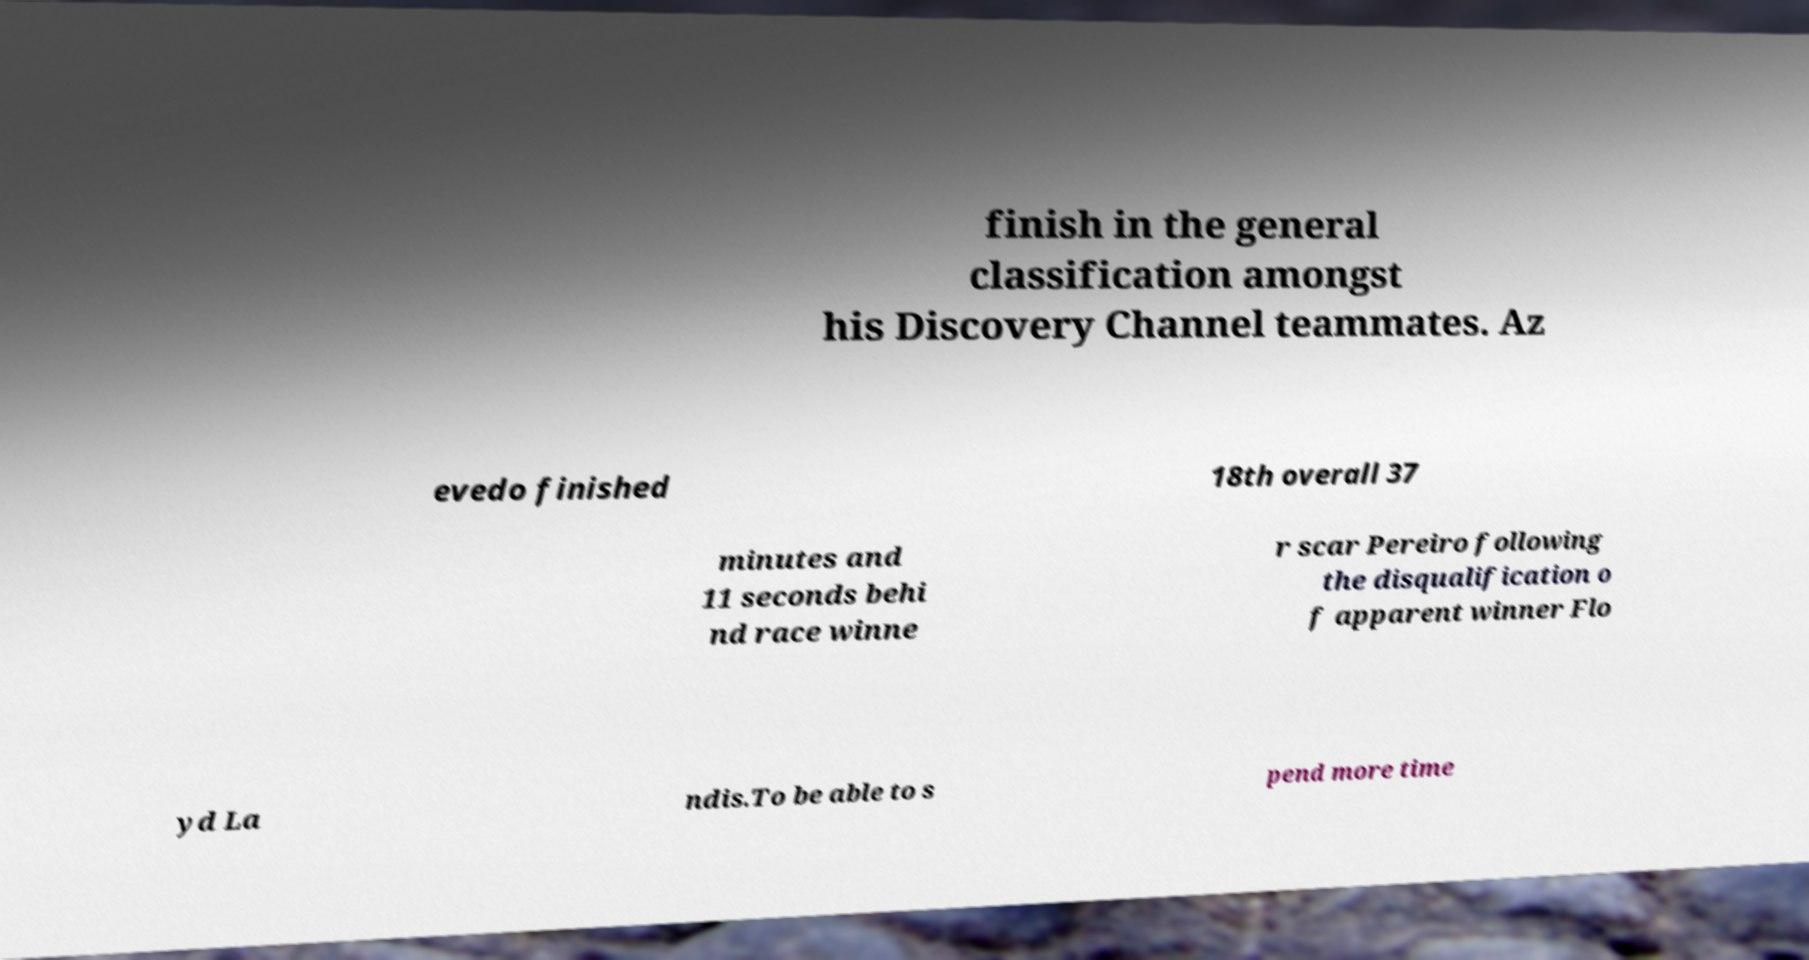Can you read and provide the text displayed in the image?This photo seems to have some interesting text. Can you extract and type it out for me? finish in the general classification amongst his Discovery Channel teammates. Az evedo finished 18th overall 37 minutes and 11 seconds behi nd race winne r scar Pereiro following the disqualification o f apparent winner Flo yd La ndis.To be able to s pend more time 